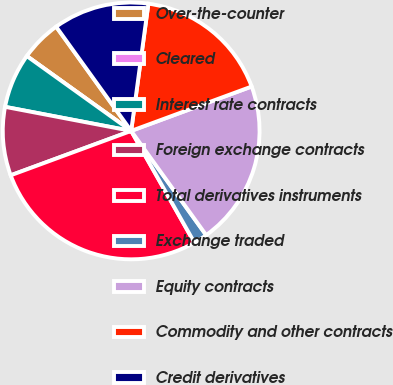<chart> <loc_0><loc_0><loc_500><loc_500><pie_chart><fcel>Over-the-counter<fcel>Cleared<fcel>Interest rate contracts<fcel>Foreign exchange contracts<fcel>Total derivatives instruments<fcel>Exchange traded<fcel>Equity contracts<fcel>Commodity and other contracts<fcel>Credit derivatives<nl><fcel>5.17%<fcel>0.0%<fcel>6.9%<fcel>8.62%<fcel>27.58%<fcel>1.73%<fcel>20.69%<fcel>17.24%<fcel>12.07%<nl></chart> 